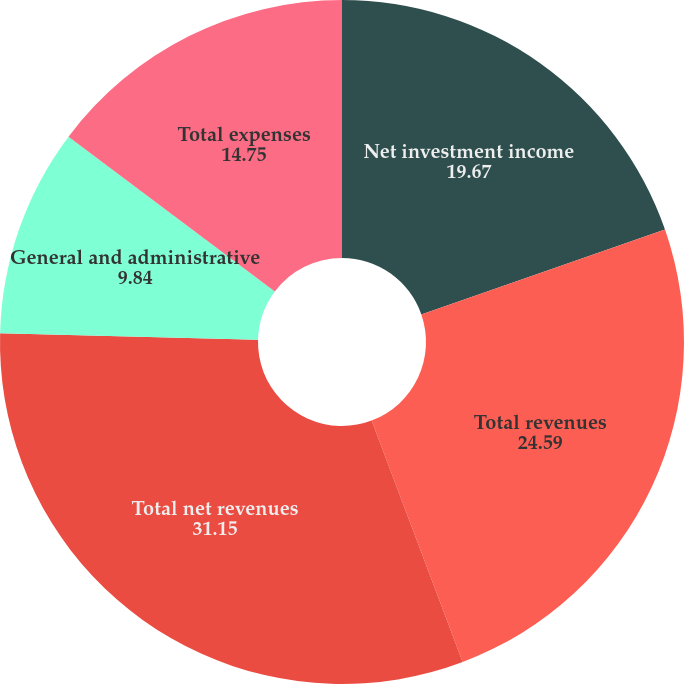<chart> <loc_0><loc_0><loc_500><loc_500><pie_chart><fcel>Net investment income<fcel>Total revenues<fcel>Total net revenues<fcel>General and administrative<fcel>Total expenses<nl><fcel>19.67%<fcel>24.59%<fcel>31.15%<fcel>9.84%<fcel>14.75%<nl></chart> 